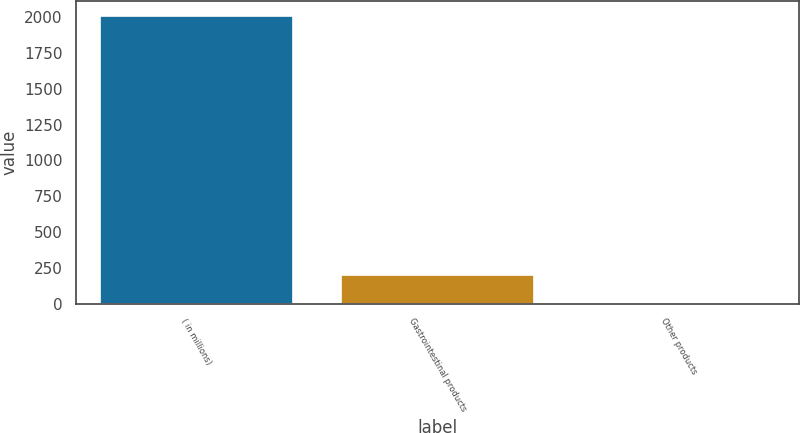Convert chart. <chart><loc_0><loc_0><loc_500><loc_500><bar_chart><fcel>( in millions)<fcel>Gastrointestinal products<fcel>Other products<nl><fcel>2010<fcel>201.9<fcel>1<nl></chart> 